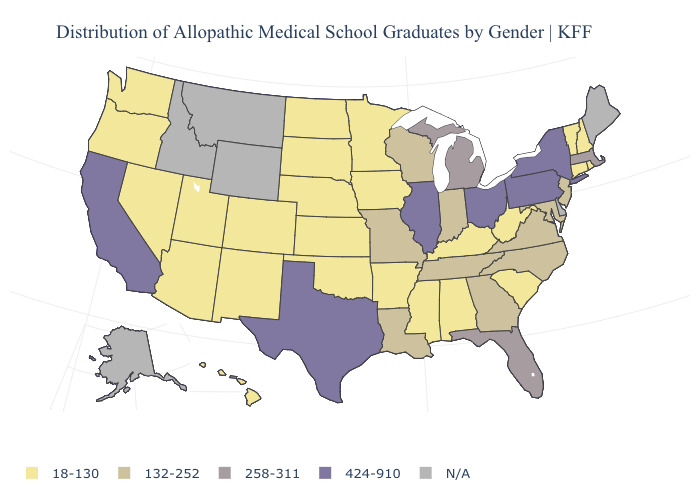Name the states that have a value in the range 18-130?
Short answer required. Alabama, Arizona, Arkansas, Colorado, Connecticut, Hawaii, Iowa, Kansas, Kentucky, Minnesota, Mississippi, Nebraska, Nevada, New Hampshire, New Mexico, North Dakota, Oklahoma, Oregon, Rhode Island, South Carolina, South Dakota, Utah, Vermont, Washington, West Virginia. How many symbols are there in the legend?
Give a very brief answer. 5. What is the lowest value in the West?
Concise answer only. 18-130. Which states have the highest value in the USA?
Be succinct. California, Illinois, New York, Ohio, Pennsylvania, Texas. What is the lowest value in the USA?
Give a very brief answer. 18-130. What is the lowest value in the USA?
Short answer required. 18-130. Which states have the lowest value in the MidWest?
Be succinct. Iowa, Kansas, Minnesota, Nebraska, North Dakota, South Dakota. Does Texas have the highest value in the USA?
Keep it brief. Yes. What is the highest value in the South ?
Be succinct. 424-910. Name the states that have a value in the range 258-311?
Concise answer only. Florida, Massachusetts, Michigan. What is the value of Arkansas?
Be succinct. 18-130. What is the value of Massachusetts?
Answer briefly. 258-311. Which states have the highest value in the USA?
Write a very short answer. California, Illinois, New York, Ohio, Pennsylvania, Texas. Name the states that have a value in the range 258-311?
Answer briefly. Florida, Massachusetts, Michigan. 